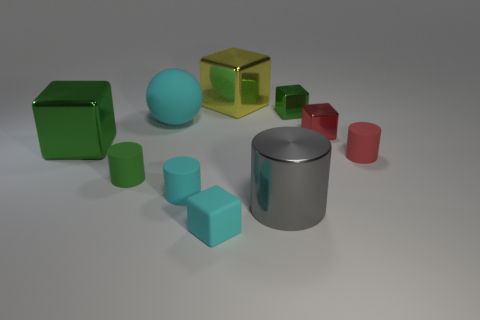Subtract all cyan cubes. How many cubes are left? 4 Subtract all small red blocks. How many blocks are left? 4 Subtract all gray blocks. Subtract all blue balls. How many blocks are left? 5 Subtract all cylinders. How many objects are left? 6 Subtract 0 purple blocks. How many objects are left? 10 Subtract all big spheres. Subtract all big gray cylinders. How many objects are left? 8 Add 7 large balls. How many large balls are left? 8 Add 9 small cyan cylinders. How many small cyan cylinders exist? 10 